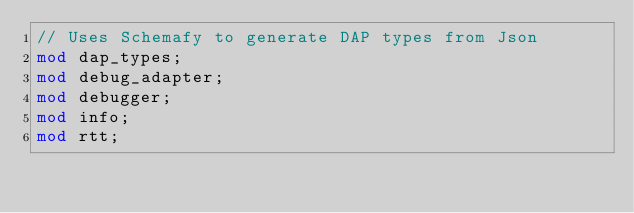Convert code to text. <code><loc_0><loc_0><loc_500><loc_500><_Rust_>// Uses Schemafy to generate DAP types from Json
mod dap_types;
mod debug_adapter;
mod debugger;
mod info;
mod rtt;
</code> 